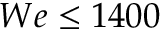<formula> <loc_0><loc_0><loc_500><loc_500>W e \leq 1 4 0 0</formula> 